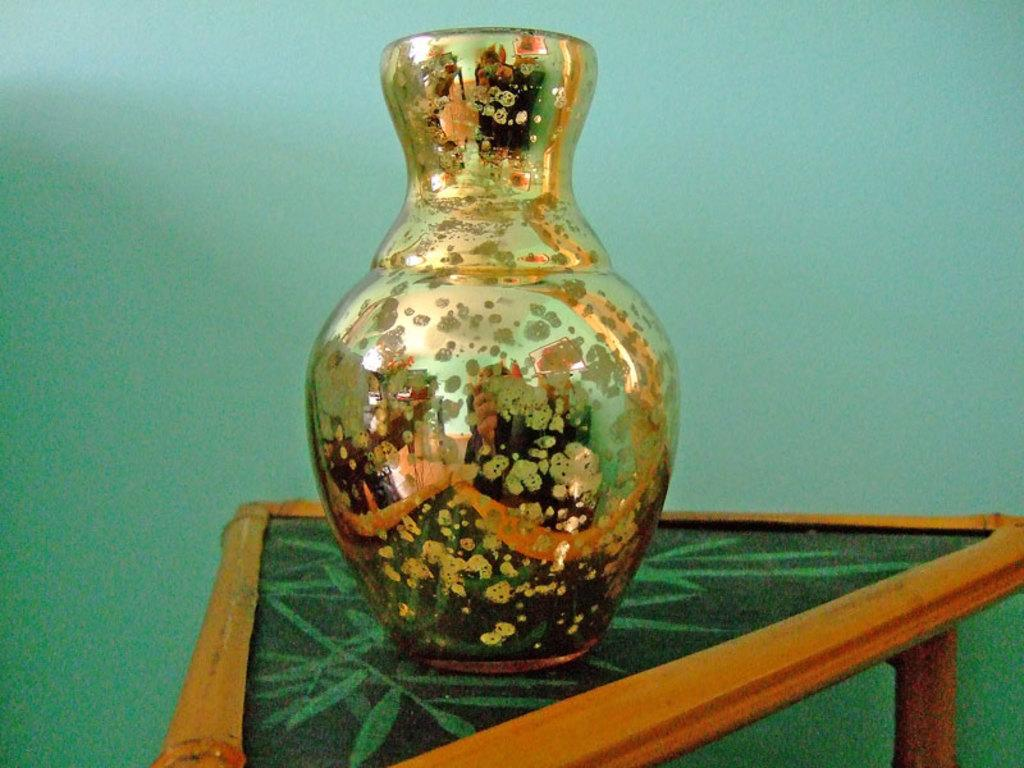What object can be seen in the image? There is a vase in the image. Where is the vase located? The vase is on a table. What can be seen in the background of the image? There is a wall visible in the background of the image. What type of toys can be seen hanging from the vase in the image? There are no toys present in the image, and the vase is not depicted as having any hanging from it. 